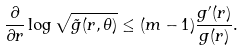Convert formula to latex. <formula><loc_0><loc_0><loc_500><loc_500>\frac { \partial } { \partial r } \log \sqrt { \tilde { g } ( r , \theta ) } \leq ( m - 1 ) \frac { g ^ { \prime } ( r ) } { g ( r ) } .</formula> 